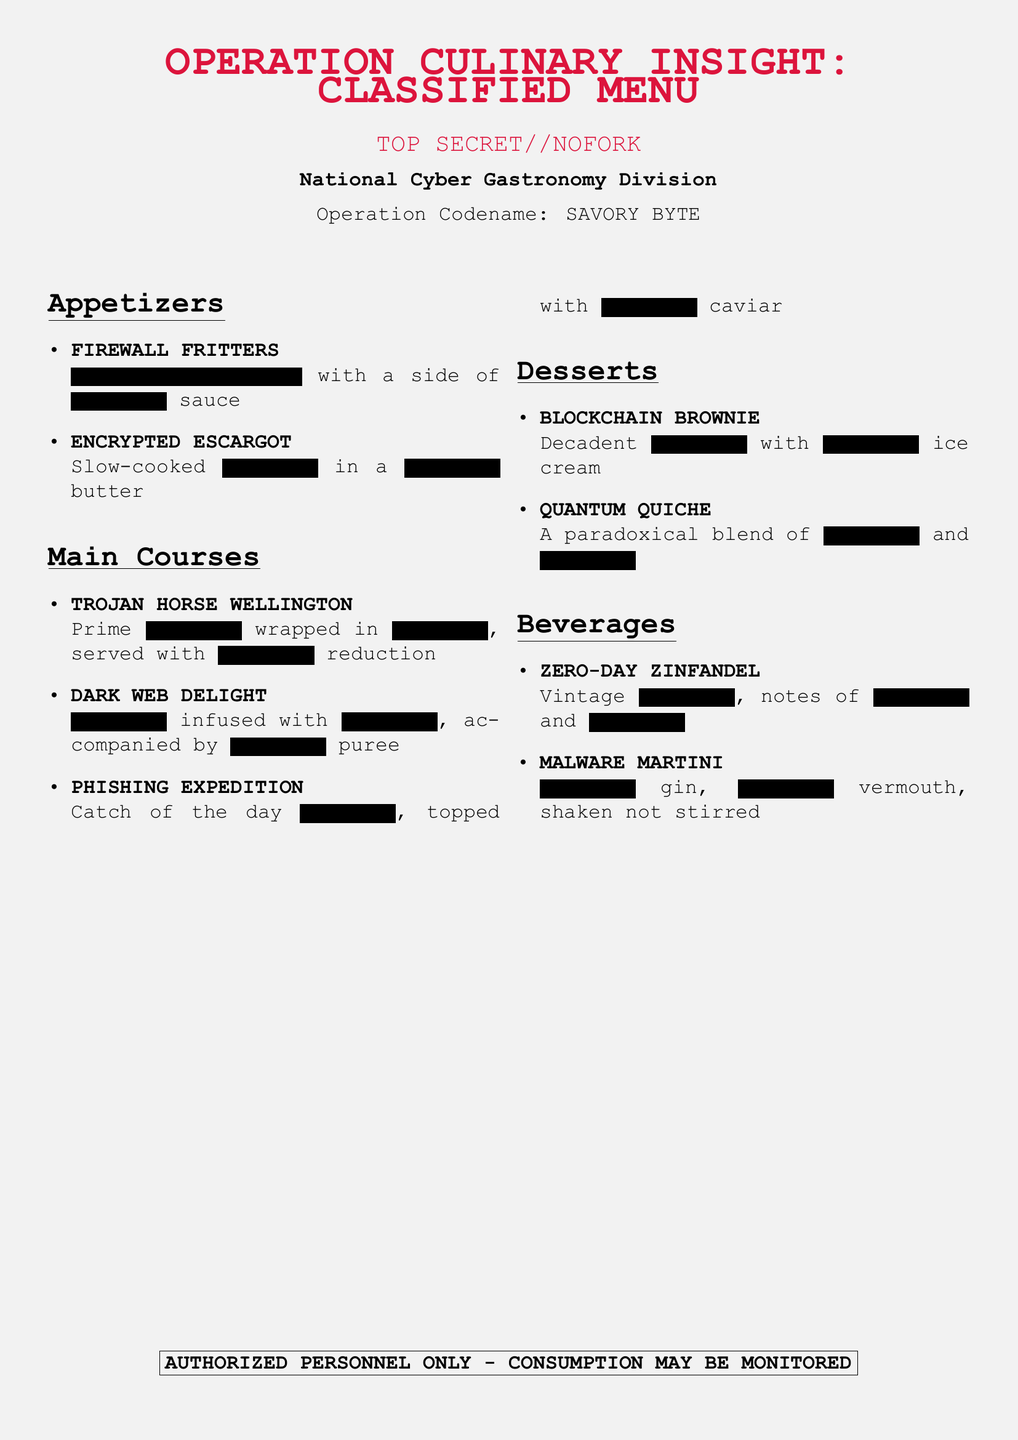What is the title of the document? The title of the document is emphasized as it introduces the subject matter of the menu, which is "OPERATION CULINARY INSIGHT: CLASSIFIED MENU."
Answer: OPERATION CULINARY INSIGHT: CLASSIFIED MENU What is the codename for the operation? The operation codename is provided under the main title to signify the theme, which is "SAVORY BYTE."
Answer: SAVORY BYTE What dish is represented by the codename "FIREWALL FRITTERS"? "FIREWALL FRITTERS" is listed as an appetizer in the menu document.
Answer: Appetizer Which beverage features gin? The specific beverage that includes gin is labeled in the menu as "MALWARE MARTINI."
Answer: MALWARE MARTINI How many main courses are listed? The number of main courses can be counted from the document, which includes three distinct items.
Answer: 3 What type of dessert is "BLOCKCHAIN BROWNIE"? This dessert is categorized under the dessert section of the menu, specifically named "BLOCKCHAIN BROWNIE."
Answer: Dessert Which dish has seafood as a feature? The dish featuring seafood is identified as "PHISHING EXPEDITION," indicating that it involves the catch of the day.
Answer: PHISHING EXPEDITION What type of wine is mentioned? The document includes a wine option, specifically referred to as "ZERO-DAY ZINFANDEL."
Answer: ZERO-DAY ZINFANDEL What is the color of the document background? The background of the document has a light gray color, as specified at the top.
Answer: Gray What phrase is highlighted for personnel access? The section at the bottom of the document emphasizes that it is for "AUTHORIZED PERSONNEL ONLY."
Answer: AUTHORIZED PERSONNEL ONLY 